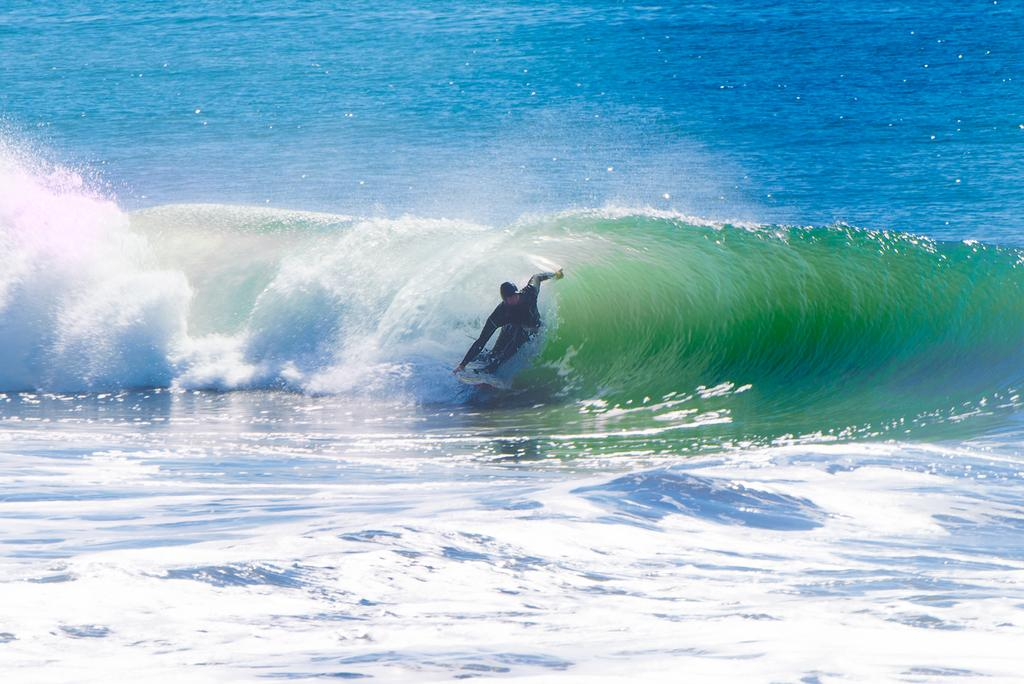What is the main subject of the image? There is a person in the image. What activity is the person engaged in? The person is surfing on water. What tool or equipment is the person using for this activity? The person is using a surfboard. Is the person generating steam while surfing in the image? There is no indication of steam generation in the image, as the person is surfing on water. 